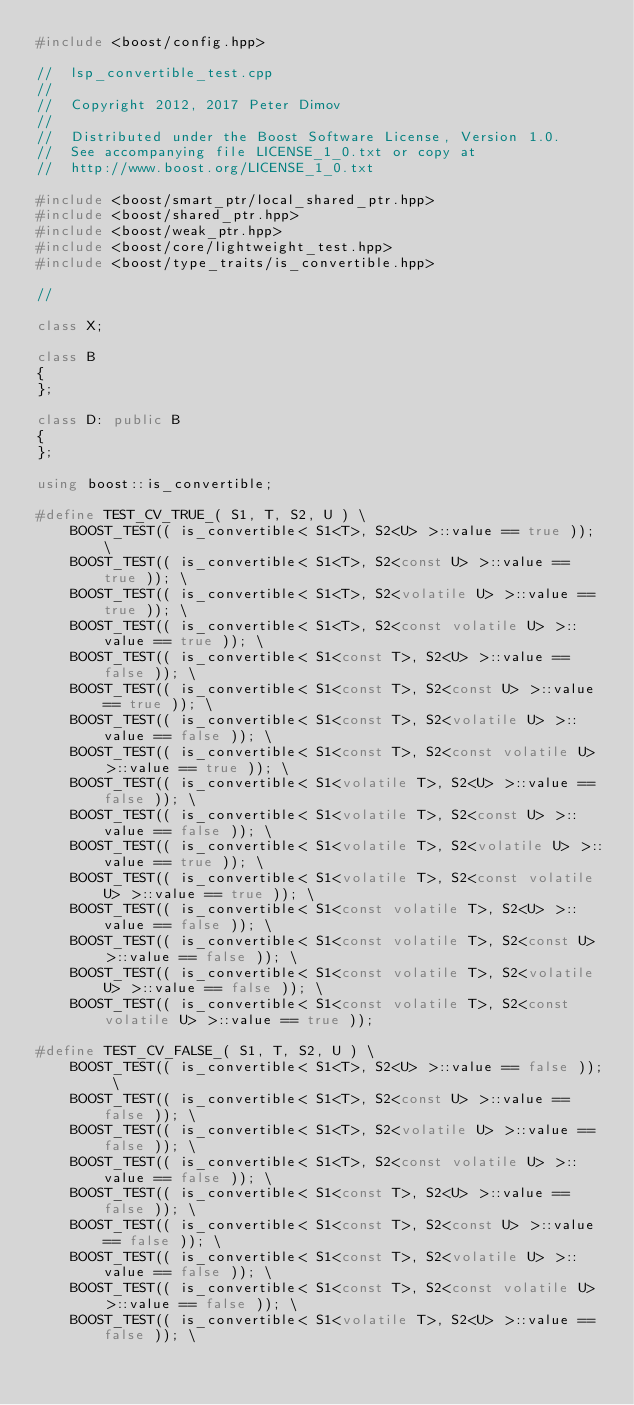<code> <loc_0><loc_0><loc_500><loc_500><_C++_>#include <boost/config.hpp>

//  lsp_convertible_test.cpp
//
//  Copyright 2012, 2017 Peter Dimov
//
//  Distributed under the Boost Software License, Version 1.0.
//  See accompanying file LICENSE_1_0.txt or copy at
//  http://www.boost.org/LICENSE_1_0.txt

#include <boost/smart_ptr/local_shared_ptr.hpp>
#include <boost/shared_ptr.hpp>
#include <boost/weak_ptr.hpp>
#include <boost/core/lightweight_test.hpp>
#include <boost/type_traits/is_convertible.hpp>

//

class X;

class B
{
};

class D: public B
{
};

using boost::is_convertible;

#define TEST_CV_TRUE_( S1, T, S2, U ) \
    BOOST_TEST(( is_convertible< S1<T>, S2<U> >::value == true )); \
    BOOST_TEST(( is_convertible< S1<T>, S2<const U> >::value == true )); \
    BOOST_TEST(( is_convertible< S1<T>, S2<volatile U> >::value == true )); \
    BOOST_TEST(( is_convertible< S1<T>, S2<const volatile U> >::value == true )); \
    BOOST_TEST(( is_convertible< S1<const T>, S2<U> >::value == false )); \
    BOOST_TEST(( is_convertible< S1<const T>, S2<const U> >::value == true )); \
    BOOST_TEST(( is_convertible< S1<const T>, S2<volatile U> >::value == false )); \
    BOOST_TEST(( is_convertible< S1<const T>, S2<const volatile U> >::value == true )); \
    BOOST_TEST(( is_convertible< S1<volatile T>, S2<U> >::value == false )); \
    BOOST_TEST(( is_convertible< S1<volatile T>, S2<const U> >::value == false )); \
    BOOST_TEST(( is_convertible< S1<volatile T>, S2<volatile U> >::value == true )); \
    BOOST_TEST(( is_convertible< S1<volatile T>, S2<const volatile U> >::value == true )); \
    BOOST_TEST(( is_convertible< S1<const volatile T>, S2<U> >::value == false )); \
    BOOST_TEST(( is_convertible< S1<const volatile T>, S2<const U> >::value == false )); \
    BOOST_TEST(( is_convertible< S1<const volatile T>, S2<volatile U> >::value == false )); \
    BOOST_TEST(( is_convertible< S1<const volatile T>, S2<const volatile U> >::value == true ));

#define TEST_CV_FALSE_( S1, T, S2, U ) \
    BOOST_TEST(( is_convertible< S1<T>, S2<U> >::value == false )); \
    BOOST_TEST(( is_convertible< S1<T>, S2<const U> >::value == false )); \
    BOOST_TEST(( is_convertible< S1<T>, S2<volatile U> >::value == false )); \
    BOOST_TEST(( is_convertible< S1<T>, S2<const volatile U> >::value == false )); \
    BOOST_TEST(( is_convertible< S1<const T>, S2<U> >::value == false )); \
    BOOST_TEST(( is_convertible< S1<const T>, S2<const U> >::value == false )); \
    BOOST_TEST(( is_convertible< S1<const T>, S2<volatile U> >::value == false )); \
    BOOST_TEST(( is_convertible< S1<const T>, S2<const volatile U> >::value == false )); \
    BOOST_TEST(( is_convertible< S1<volatile T>, S2<U> >::value == false )); \</code> 